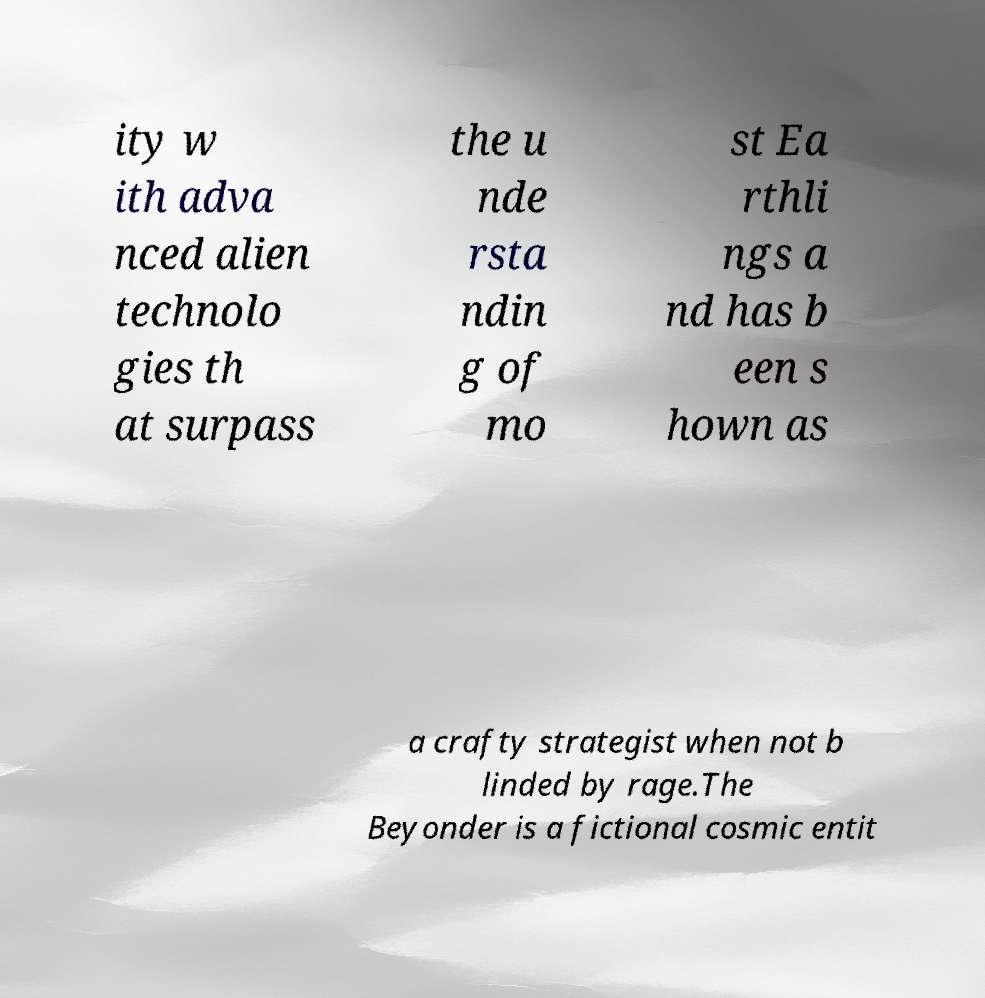Can you accurately transcribe the text from the provided image for me? ity w ith adva nced alien technolo gies th at surpass the u nde rsta ndin g of mo st Ea rthli ngs a nd has b een s hown as a crafty strategist when not b linded by rage.The Beyonder is a fictional cosmic entit 